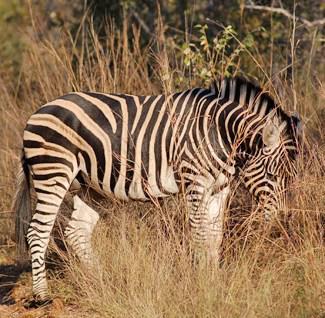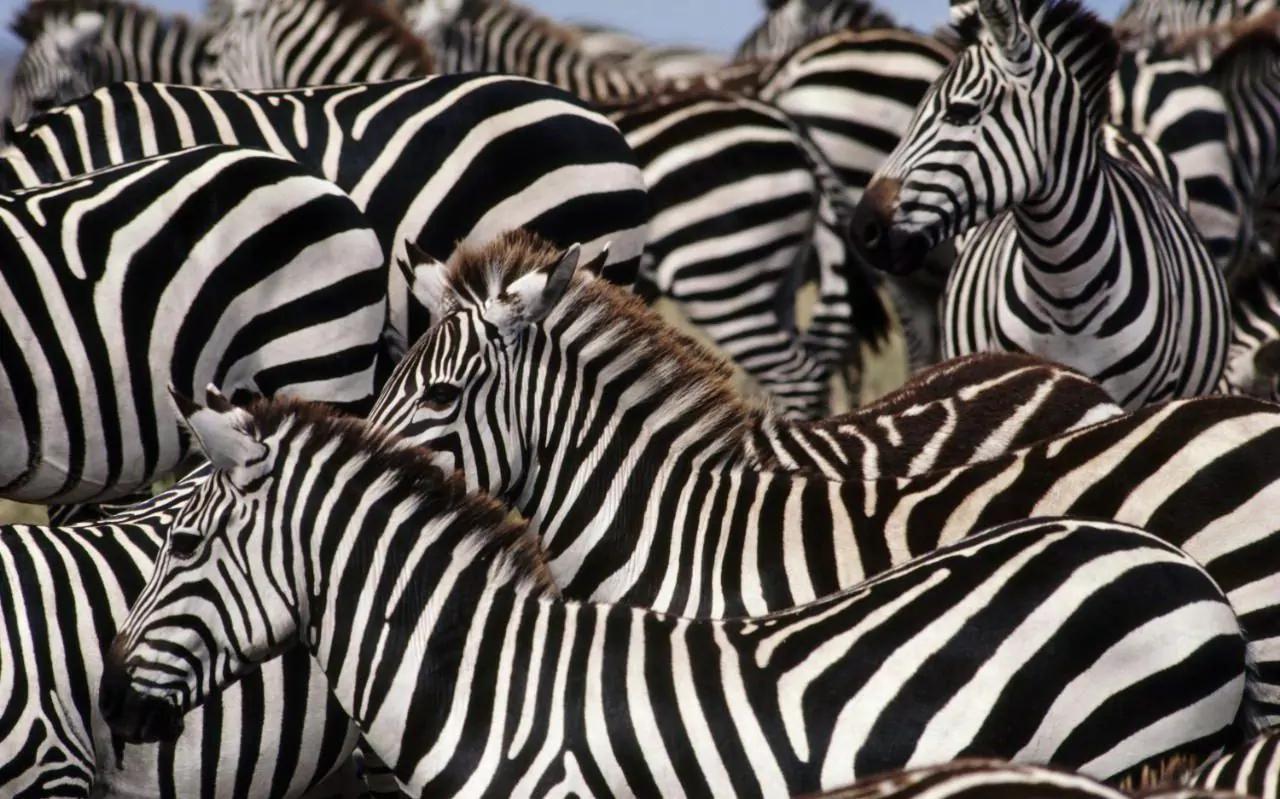The first image is the image on the left, the second image is the image on the right. Assess this claim about the two images: "The right image contains no more than two zebras.". Correct or not? Answer yes or no. No. The first image is the image on the left, the second image is the image on the right. Considering the images on both sides, is "Each image contains multiple zebras, and one image shows exactly two zebras posed with one's head over the other's back." valid? Answer yes or no. No. 